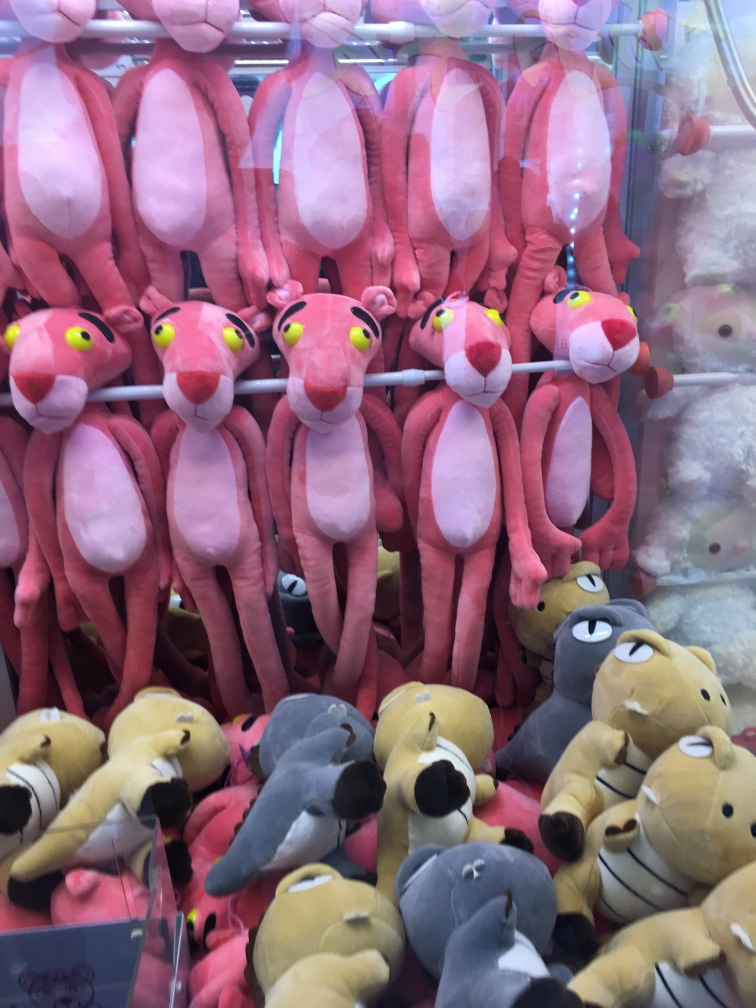Are there any toys that seem out of place? Upon closer inspection, most of the toys have a consistent cartoonish aesthetic. There aren't any that seem drastically out of place, but the variety of animals, including what appear to be penguins and a certain lovable lazy bear character type, offers a diverse selection for different preferences. How popular are these types of toys? Plush toys like these have remained popular over the years. They are timeless in their appeal, often associated with childhood memories, and they continue to find audiences in people who appreciate animated characters or enjoy the comfort of a soft toy. 